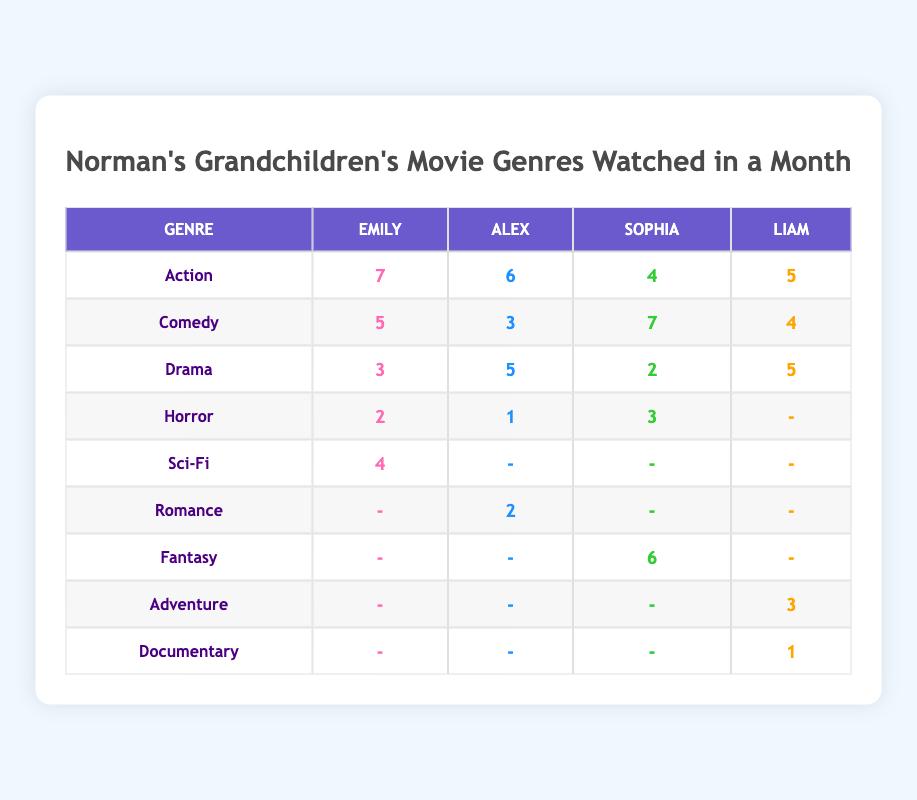What genre did Emily watch the most? Emily watched 7 Action movies, which is the highest among all genres she watched.
Answer: Action How many total movies did Alex watch across all genres? Alex watched a total of 6 (Action) + 3 (Comedy) + 5 (Drama) + 1 (Horror) + 2 (Romance) = 17 movies.
Answer: 17 Did Sophia watch more Comedy than Emily? Sophia watched 7 Comedy movies, while Emily watched 5, thus Sophia watched more.
Answer: Yes What is the average number of Horror movies watched by the grandchildren? The grandchildren watched Horror movies as follows: 2 (Emily) + 1 (Alex) + 3 (Sophia) + 0 (Liam) = 6. There are 4 grandchildren, so the average is 6 / 4 = 1.5.
Answer: 1.5 Which grandchild watched the least number of Drama movies, and how many? Looking at the Drama values: Emily watched 3, Alex watched 5, Sophia watched 2, and Liam watched 5. Sophia watched the least with 2.
Answer: Sophia, 2 What percentage of total movies watched by Liam were in the Comedy genre? Liam watched a total of 5 (Action) + 3 (Adventure) + 4 (Comedy) + 5 (Drama) + 1 (Documentary) = 18 movies. The Comedy movies make up (4 / 18) * 100 = 22.22%.
Answer: 22.22% Which genre had the highest total watch count across all grandchildren? The total watch for each genre: Action (22) + Comedy (19) + Drama (15) + Horror (6) + Sci-Fi (4) + Romance (2) + Fantasy (6) + Adventure (3) + Documentary (1). Action has the highest count of 22.
Answer: Action Did any grandchild watch no Sci-Fi movies? Both Alex, Sophia, and Liam did not watch any Sci-Fi movies, as indicated by the '-' in their respective cells for Sci-Fi.
Answer: Yes What is the difference in the number of Horror movies watched between Emily and Alex? Emily watched 2 Horror movies and Alex watched 1, thus the difference is 2 - 1 = 1.
Answer: 1 